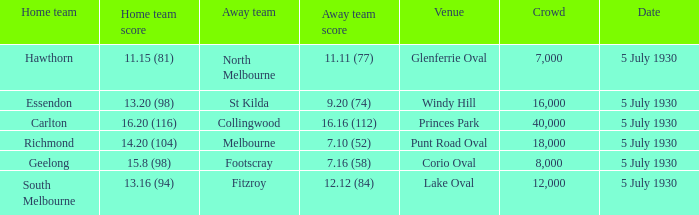Who is the away side at corio oval? Footscray. 